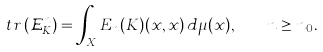<formula> <loc_0><loc_0><loc_500><loc_500>t r \, ( \mathcal { E } ^ { n } _ { K } ) = \int _ { X } E _ { n } ( K ) ( x , x ) \, d \mu ( x ) , \quad n \geq n _ { 0 } .</formula> 